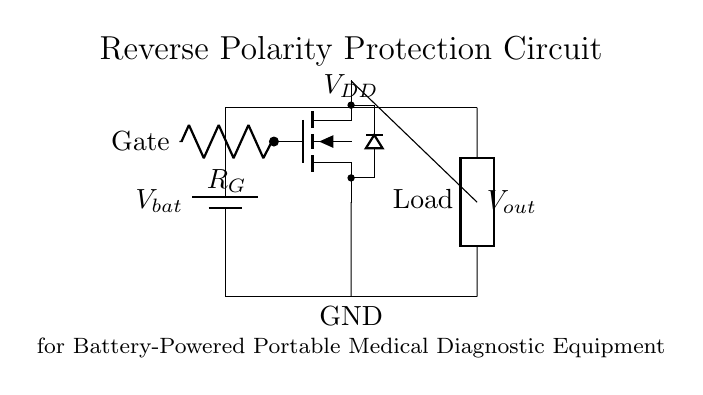What is the battery voltage represented in the circuit? The circuit shows a battery labeled as V_{bat}, which represents the voltage supply for the circuit.
Answer: V_bat What component is used to provide reverse polarity protection? The circuit uses an N-channel MOSFET, which is indicated by the nfet label, and is responsible for allowing current flow while blocking reverse current.
Answer: N-channel MOSFET What is the purpose of the resistor labeled R_G? The resistor R_G is connected to the gate of the MOSFET and serves to control the gate voltage, thereby regulating the operation of the MOSFET for proper current flow.
Answer: Control gate voltage Which direction does the current flow when the battery is connected correctly? The diagram shows that current flows from the positive terminal of the battery (V_{bat}) through the load, which indicates the correct direction of current flow in the circuit.
Answer: From positive to load What happens if the battery is connected with reverse polarity? If the battery is connected with reverse polarity, the MOSFET will block the current flow because it will not turn on, thus protecting the circuit from damage.
Answer: Current flow is blocked What are the output voltage and ground labeled as in the circuit? The output voltage is labeled as V_{out}, and the ground connection is denoted as GND, providing necessary references for voltage levels in the circuit.
Answer: V_out and GND What is the purpose of the load component in this circuit? The load is connected in the circuit to represent the device or component that consumes power from the battery while supplying the necessary function for the portable medical diagnostic equipment.
Answer: Power consumption device 